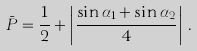<formula> <loc_0><loc_0><loc_500><loc_500>\bar { P } = \frac { 1 } { 2 } + \left | \frac { \sin \alpha _ { 1 } + \sin \alpha _ { 2 } } { 4 } \right | \, .</formula> 